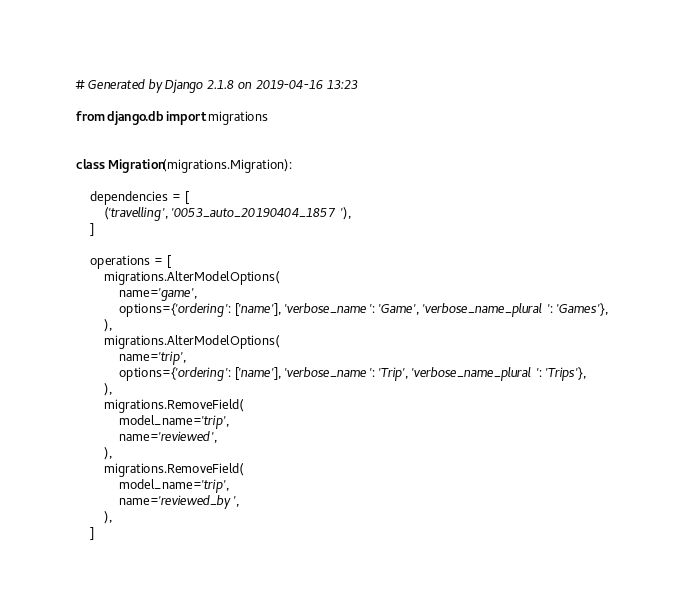Convert code to text. <code><loc_0><loc_0><loc_500><loc_500><_Python_># Generated by Django 2.1.8 on 2019-04-16 13:23

from django.db import migrations


class Migration(migrations.Migration):

    dependencies = [
        ('travelling', '0053_auto_20190404_1857'),
    ]

    operations = [
        migrations.AlterModelOptions(
            name='game',
            options={'ordering': ['name'], 'verbose_name': 'Game', 'verbose_name_plural': 'Games'},
        ),
        migrations.AlterModelOptions(
            name='trip',
            options={'ordering': ['name'], 'verbose_name': 'Trip', 'verbose_name_plural': 'Trips'},
        ),
        migrations.RemoveField(
            model_name='trip',
            name='reviewed',
        ),
        migrations.RemoveField(
            model_name='trip',
            name='reviewed_by',
        ),
    ]
</code> 